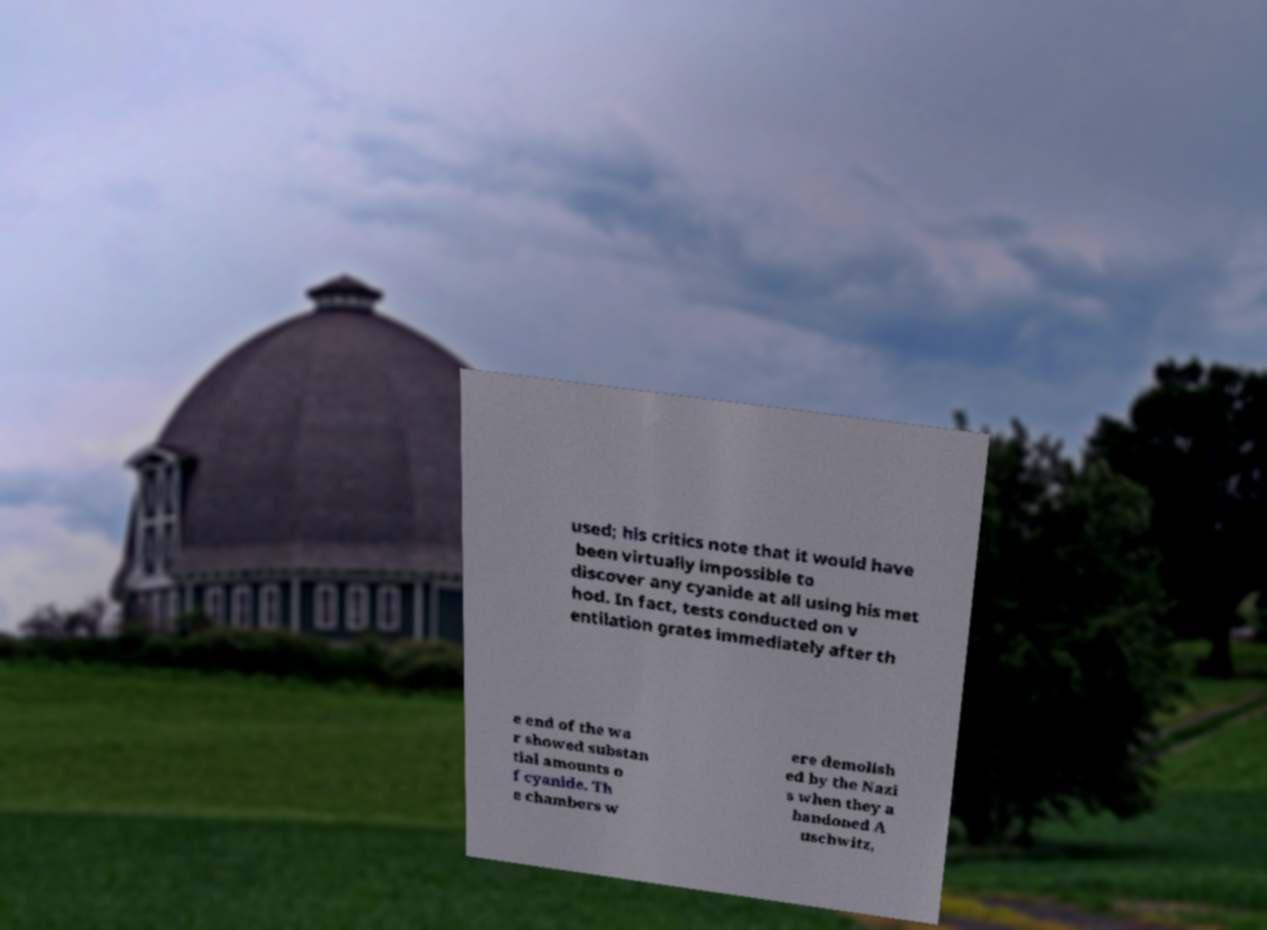There's text embedded in this image that I need extracted. Can you transcribe it verbatim? used; his critics note that it would have been virtually impossible to discover any cyanide at all using his met hod. In fact, tests conducted on v entilation grates immediately after th e end of the wa r showed substan tial amounts o f cyanide. Th e chambers w ere demolish ed by the Nazi s when they a bandoned A uschwitz, 